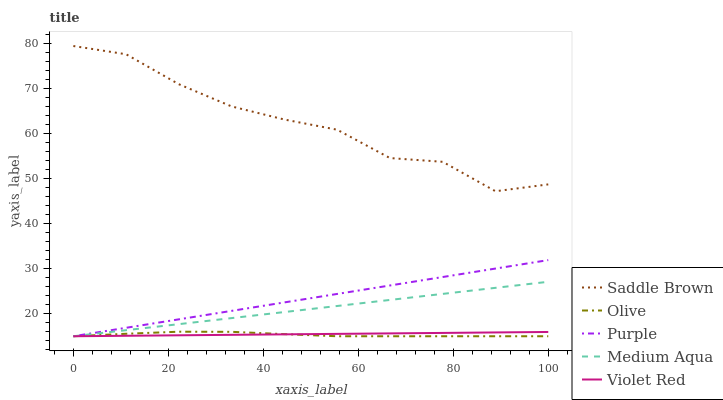Does Olive have the minimum area under the curve?
Answer yes or no. Yes. Does Saddle Brown have the maximum area under the curve?
Answer yes or no. Yes. Does Purple have the minimum area under the curve?
Answer yes or no. No. Does Purple have the maximum area under the curve?
Answer yes or no. No. Is Violet Red the smoothest?
Answer yes or no. Yes. Is Saddle Brown the roughest?
Answer yes or no. Yes. Is Purple the smoothest?
Answer yes or no. No. Is Purple the roughest?
Answer yes or no. No. Does Olive have the lowest value?
Answer yes or no. Yes. Does Saddle Brown have the lowest value?
Answer yes or no. No. Does Saddle Brown have the highest value?
Answer yes or no. Yes. Does Purple have the highest value?
Answer yes or no. No. Is Violet Red less than Saddle Brown?
Answer yes or no. Yes. Is Saddle Brown greater than Purple?
Answer yes or no. Yes. Does Olive intersect Purple?
Answer yes or no. Yes. Is Olive less than Purple?
Answer yes or no. No. Is Olive greater than Purple?
Answer yes or no. No. Does Violet Red intersect Saddle Brown?
Answer yes or no. No. 